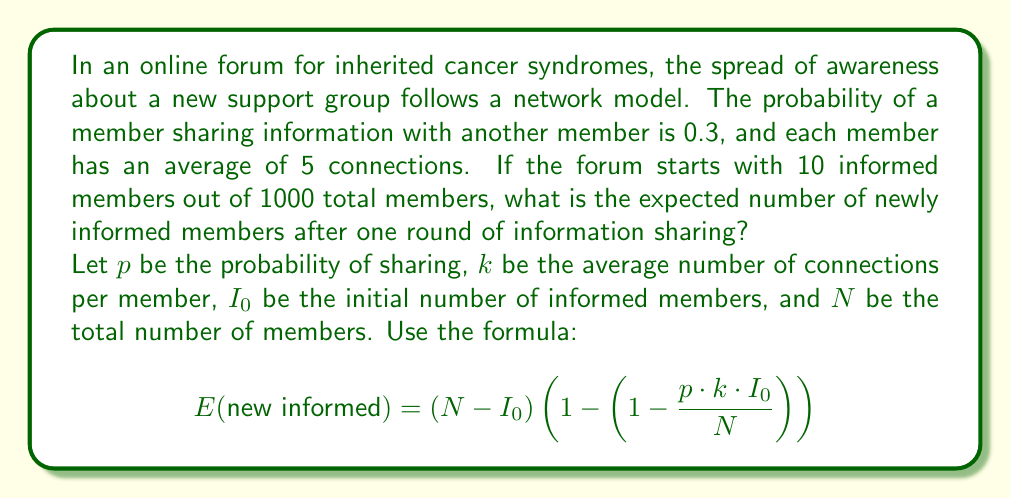Could you help me with this problem? To solve this problem, we'll use the given formula and plug in the values:

1. $p = 0.3$ (probability of sharing)
2. $k = 5$ (average connections per member)
3. $I_0 = 10$ (initial informed members)
4. $N = 1000$ (total members)

Let's break down the solution step by step:

1. Calculate $\frac{p \cdot k \cdot I_0}{N}$:
   $$\frac{0.3 \cdot 5 \cdot 10}{1000} = \frac{15}{1000} = 0.015$$

2. Calculate $\left(1 - \frac{p \cdot k \cdot I_0}{N}\right)$:
   $$1 - 0.015 = 0.985$$

3. Calculate $\left(1 - \left(1 - \frac{p \cdot k \cdot I_0}{N}\right)\right)$:
   $$1 - 0.985 = 0.015$$

4. Calculate $(N - I_0)$:
   $$1000 - 10 = 990$$

5. Finally, multiply the results from steps 3 and 4:
   $$990 \cdot 0.015 = 14.85$$

Therefore, the expected number of newly informed members after one round of information sharing is approximately 14.85.
Answer: 14.85 newly informed members 